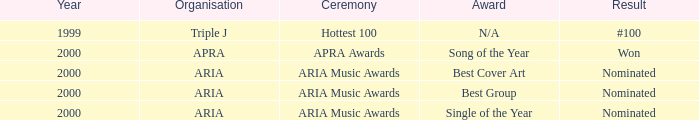What's the award for #100? N/A. 